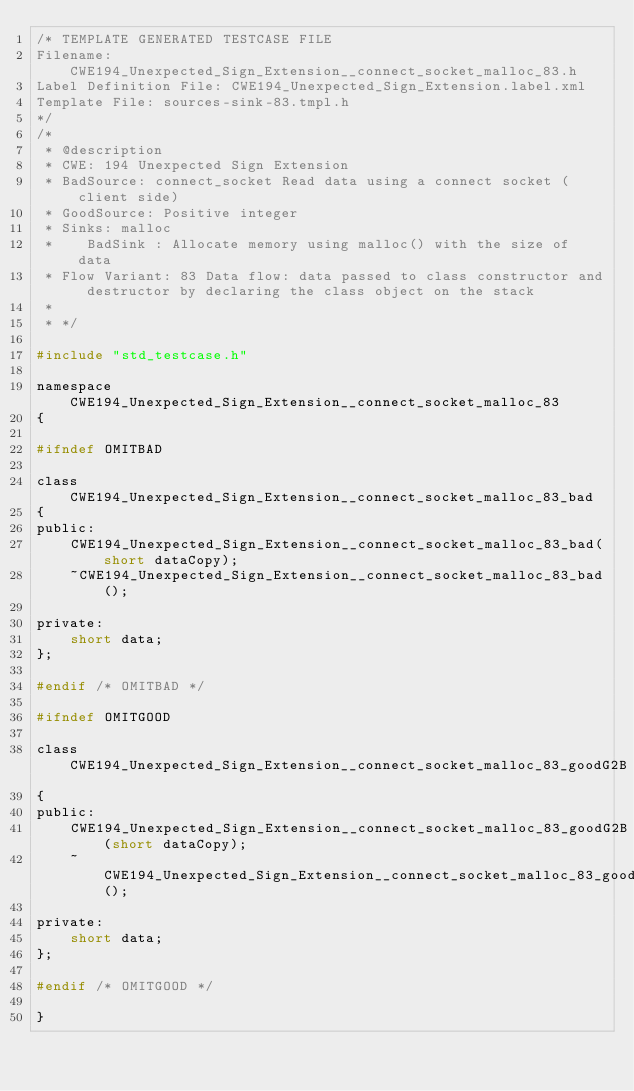Convert code to text. <code><loc_0><loc_0><loc_500><loc_500><_C_>/* TEMPLATE GENERATED TESTCASE FILE
Filename: CWE194_Unexpected_Sign_Extension__connect_socket_malloc_83.h
Label Definition File: CWE194_Unexpected_Sign_Extension.label.xml
Template File: sources-sink-83.tmpl.h
*/
/*
 * @description
 * CWE: 194 Unexpected Sign Extension
 * BadSource: connect_socket Read data using a connect socket (client side)
 * GoodSource: Positive integer
 * Sinks: malloc
 *    BadSink : Allocate memory using malloc() with the size of data
 * Flow Variant: 83 Data flow: data passed to class constructor and destructor by declaring the class object on the stack
 *
 * */

#include "std_testcase.h"

namespace CWE194_Unexpected_Sign_Extension__connect_socket_malloc_83
{

#ifndef OMITBAD

class CWE194_Unexpected_Sign_Extension__connect_socket_malloc_83_bad
{
public:
    CWE194_Unexpected_Sign_Extension__connect_socket_malloc_83_bad(short dataCopy);
    ~CWE194_Unexpected_Sign_Extension__connect_socket_malloc_83_bad();

private:
    short data;
};

#endif /* OMITBAD */

#ifndef OMITGOOD

class CWE194_Unexpected_Sign_Extension__connect_socket_malloc_83_goodG2B
{
public:
    CWE194_Unexpected_Sign_Extension__connect_socket_malloc_83_goodG2B(short dataCopy);
    ~CWE194_Unexpected_Sign_Extension__connect_socket_malloc_83_goodG2B();

private:
    short data;
};

#endif /* OMITGOOD */

}
</code> 